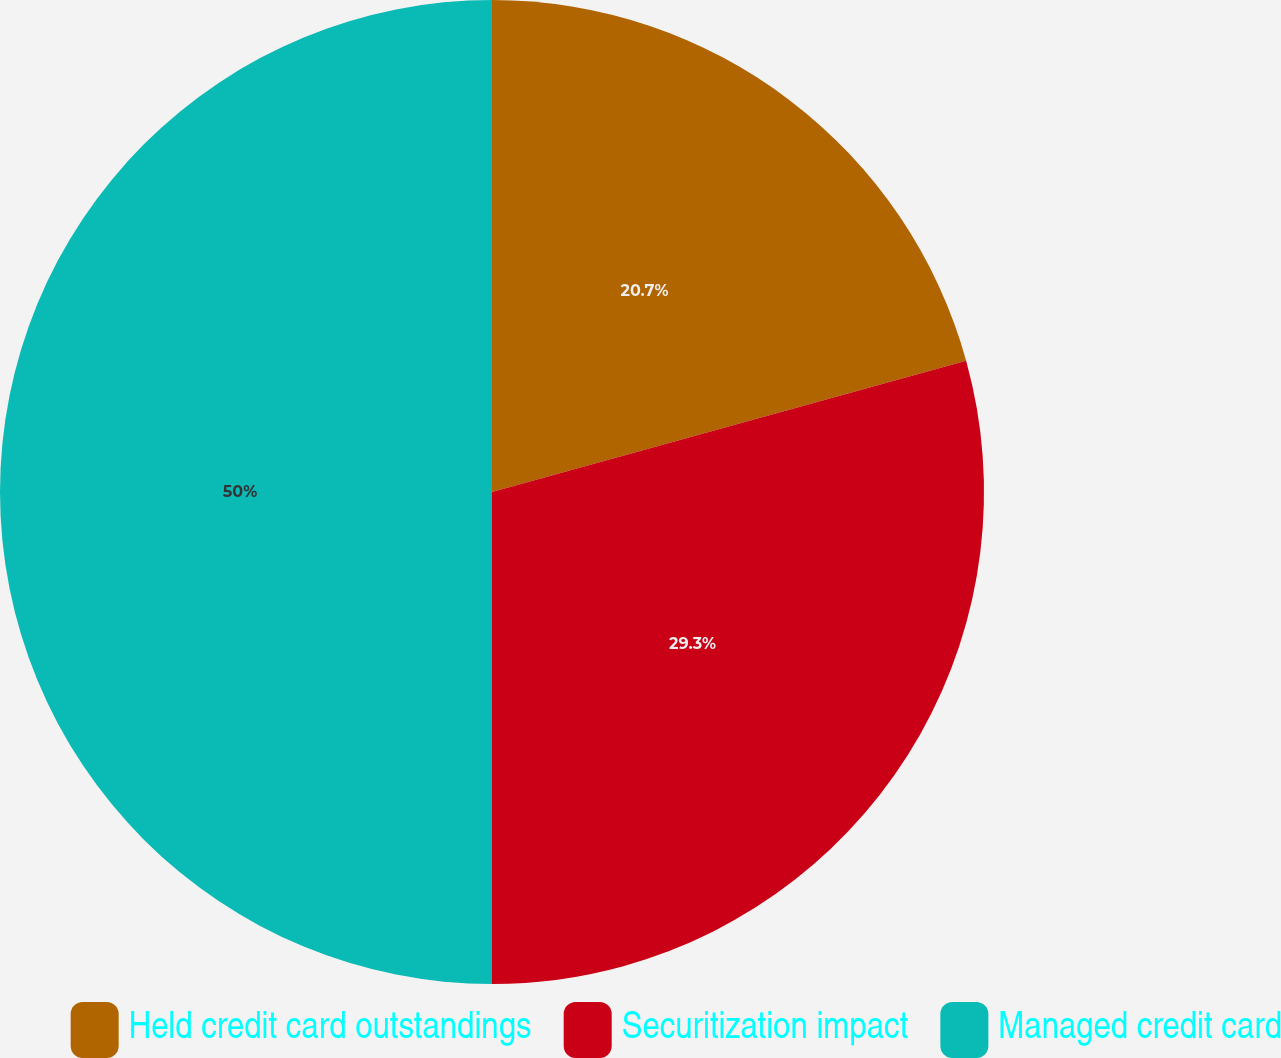<chart> <loc_0><loc_0><loc_500><loc_500><pie_chart><fcel>Held credit card outstandings<fcel>Securitization impact<fcel>Managed credit card<nl><fcel>20.7%<fcel>29.3%<fcel>50.0%<nl></chart> 